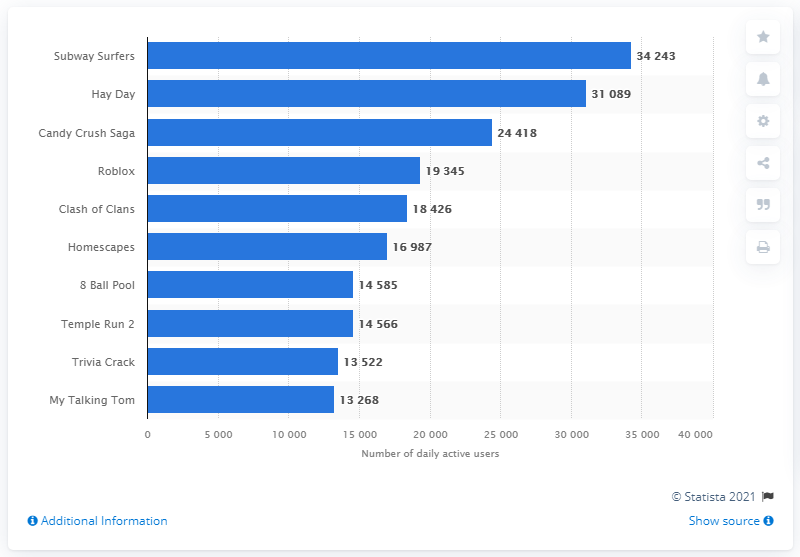Highlight a few significant elements in this photo. Candy Crush Saga placed second with over 31 thousand daily active users, making it a highly popular game. As of April 2021, Subway Surfers had a daily active user (DAU) count of 34,243. According to data collected in April 2021, the Android mobile gaming app with the highest number of daily active users in Denmark was "Subway Surfers. 